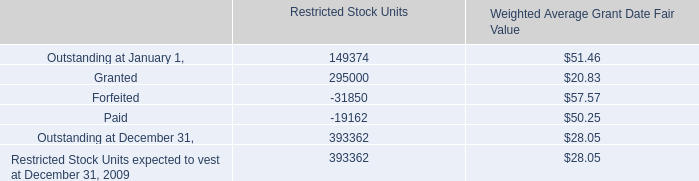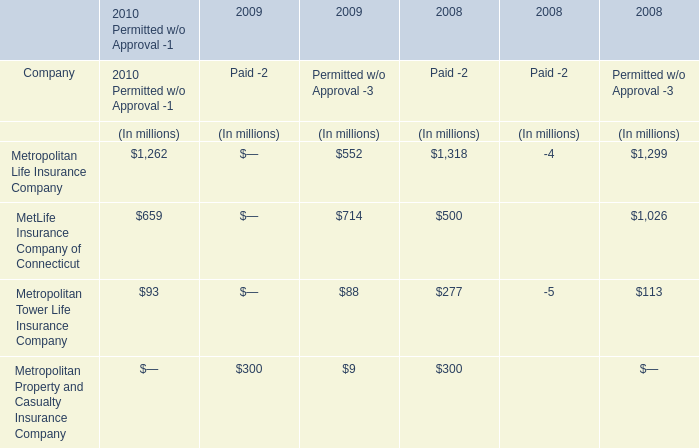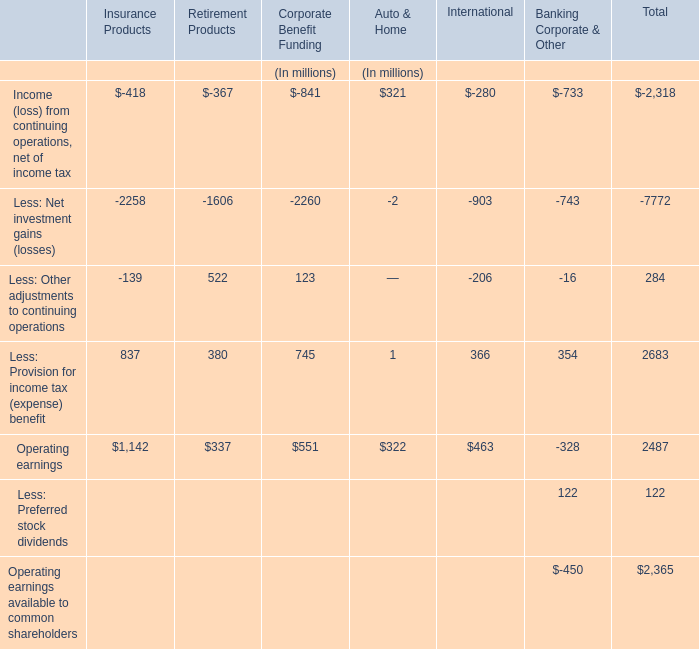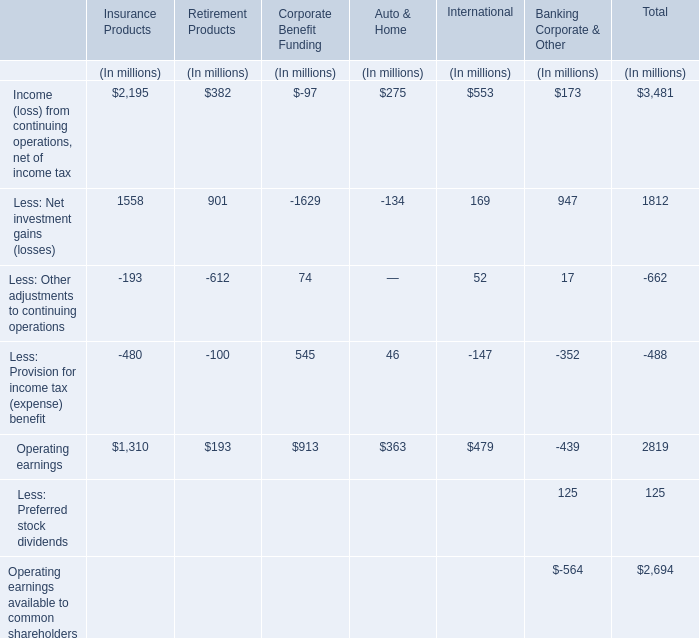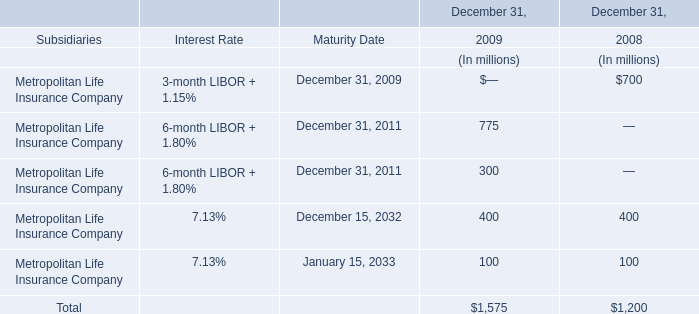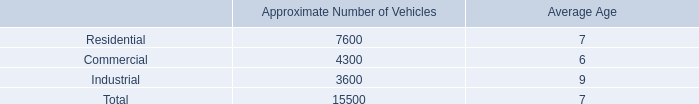What is the sum of the Operating earnings in the sections where Less: Other adjustments to continuing operations is positive? (in million) 
Computations: (337 + 551)
Answer: 888.0. 